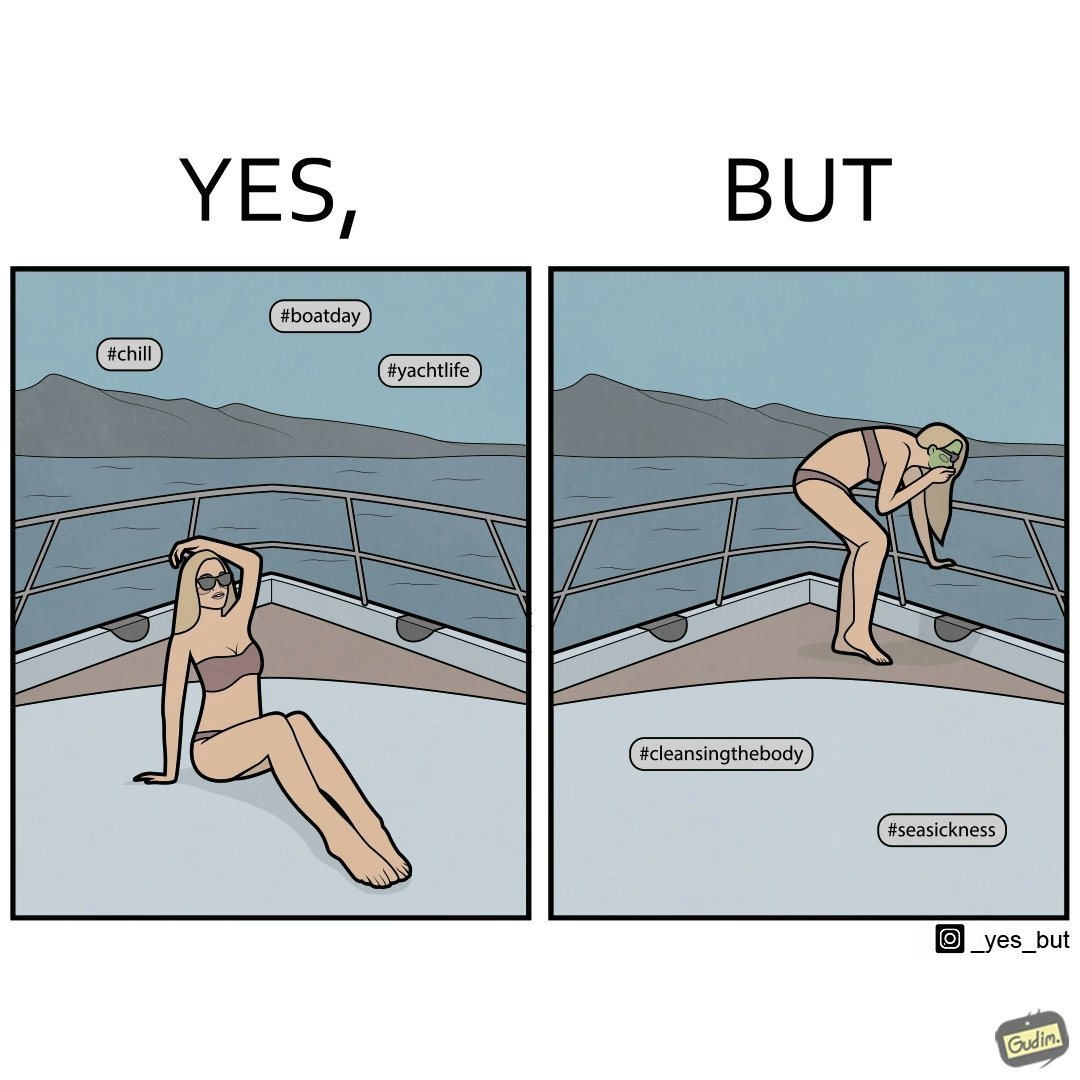Explain the humor or irony in this image. The image is ironic, because in the first image the woman is showing how she is enjoying the sea trip but whereas the second image shows how she is struggling over the trip due to sea sickness which brings up a contrast comparison between the two photos 